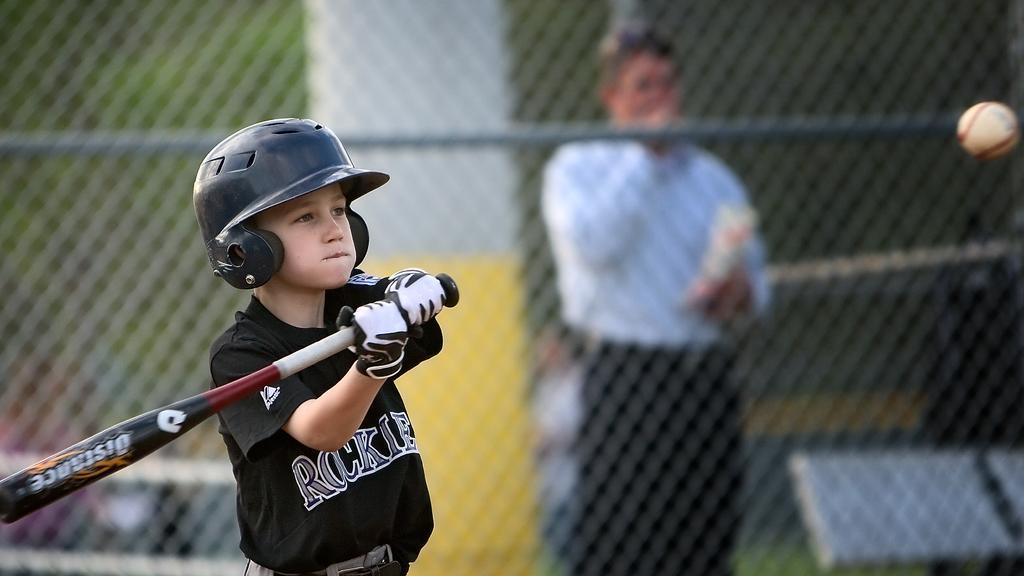Can you describe this image briefly? In this image, we can see a kid wearing a helmet and gloves and holding a bat. In the background, we can see a mesh and there is a ball and an other person standing and holding a packet. 